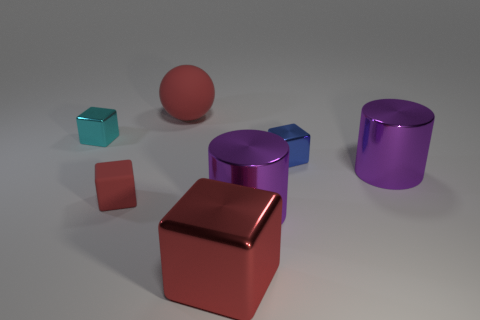Do these objects appear to be solid or hollow? The objects appear to be solid. There are no visible indications such as holes or thin edges to suggest that they might be hollow. 